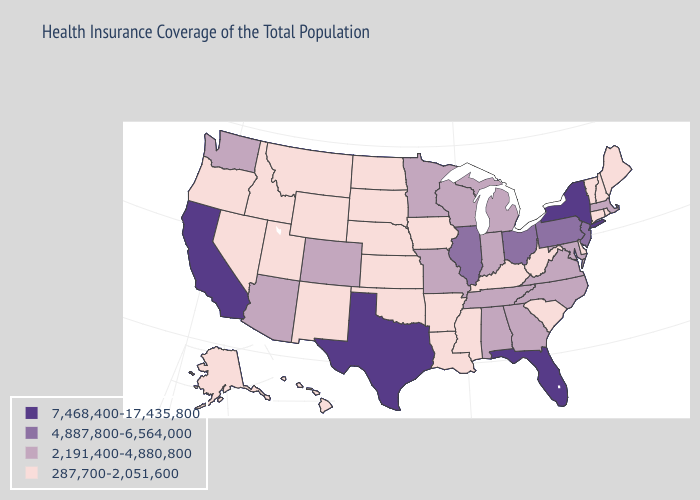Does California have the highest value in the USA?
Answer briefly. Yes. Does Minnesota have a lower value than South Dakota?
Concise answer only. No. Does Vermont have the same value as Pennsylvania?
Answer briefly. No. What is the value of Louisiana?
Short answer required. 287,700-2,051,600. Among the states that border New Mexico , which have the highest value?
Keep it brief. Texas. Which states hav the highest value in the West?
Give a very brief answer. California. Is the legend a continuous bar?
Be succinct. No. Name the states that have a value in the range 7,468,400-17,435,800?
Concise answer only. California, Florida, New York, Texas. What is the value of Michigan?
Give a very brief answer. 2,191,400-4,880,800. What is the value of California?
Answer briefly. 7,468,400-17,435,800. What is the value of New Jersey?
Write a very short answer. 4,887,800-6,564,000. Name the states that have a value in the range 4,887,800-6,564,000?
Answer briefly. Illinois, New Jersey, Ohio, Pennsylvania. Among the states that border Wisconsin , which have the lowest value?
Keep it brief. Iowa. Among the states that border Wisconsin , does Minnesota have the highest value?
Give a very brief answer. No. Which states have the highest value in the USA?
Keep it brief. California, Florida, New York, Texas. 